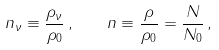<formula> <loc_0><loc_0><loc_500><loc_500>n _ { \nu } \equiv \frac { \rho _ { \nu } } { \rho _ { 0 } } \, , \quad n \equiv \frac { \rho } { \rho _ { 0 } } = \frac { N } { N _ { 0 } } \, ,</formula> 